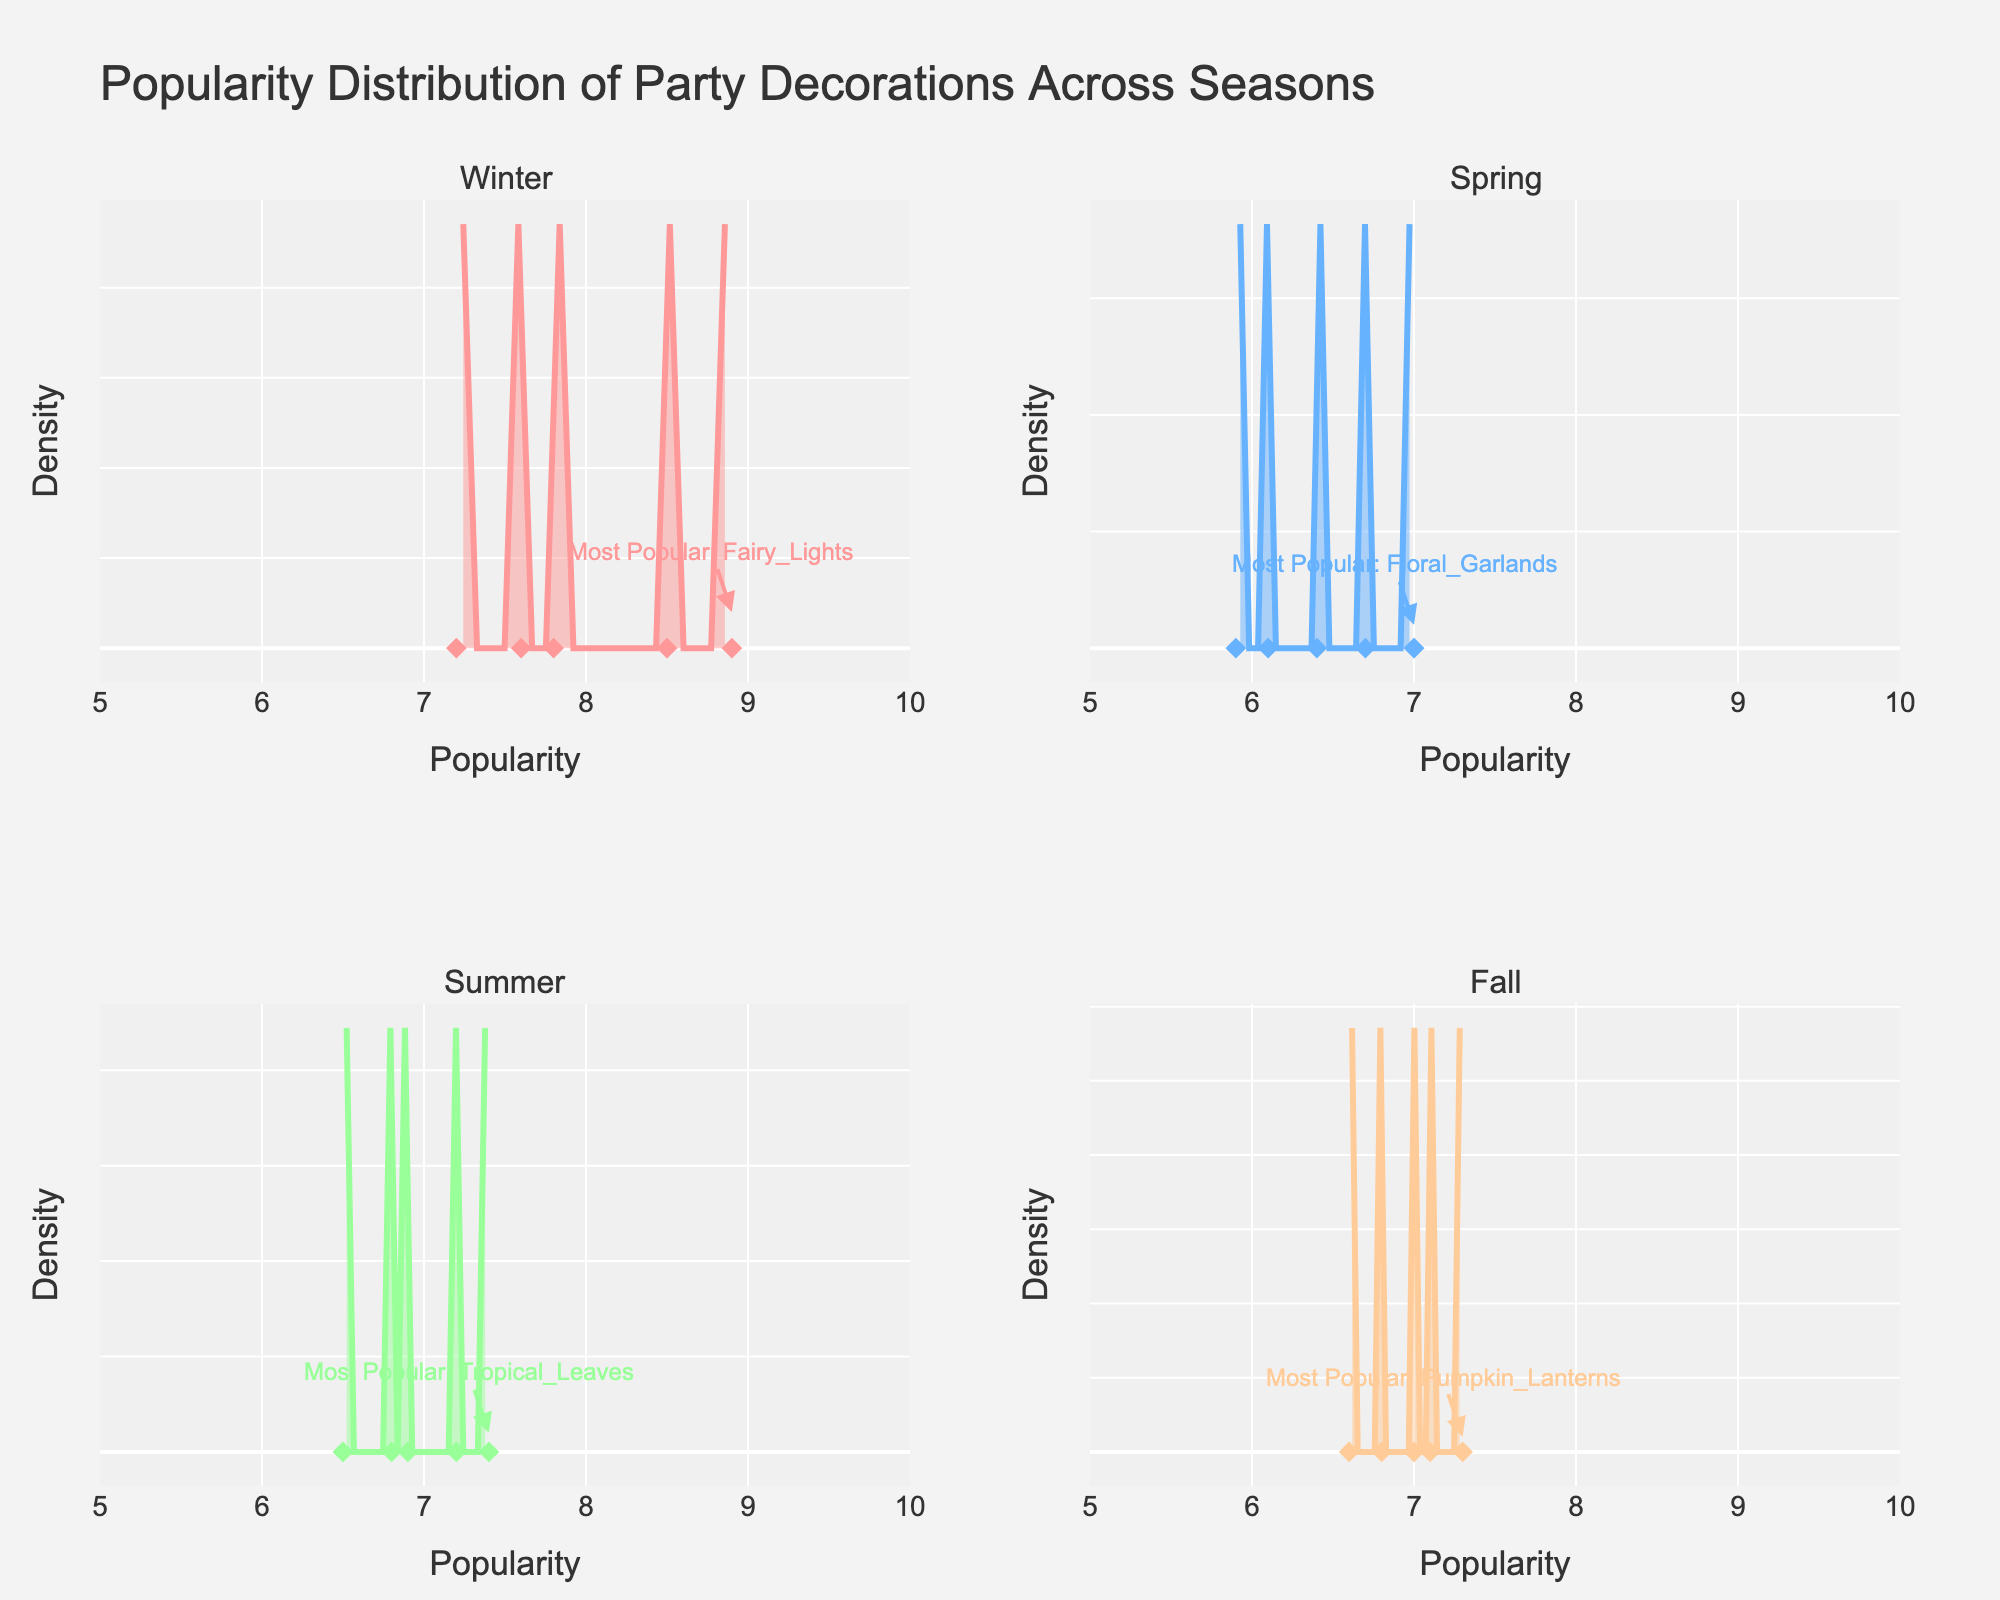What is the title of the figure? The title is usually placed at the top of the figure and clearly indicates what the data represents. In this case, it says "Popularity Distribution of Party Decorations Across Seasons."
Answer: Popularity Distribution of Party Decorations Across Seasons What is the popularity range of the decorations plotted in the figure? The x-axes of the density plots indicate the popularity range. It is set from 5 to 10 across all seasons.
Answer: 5 to 10 Which season has the most popular decoration with a popularity score of 8.9? Each subplot contains annotations for the most popular items in each season. The annotation in the Winter subplot indicates that the most popular decoration has a score of 8.9.
Answer: Winter How many seasons are compared in this figure? The subplot titles indicate the different seasons compared in the figure. There are four titles, corresponding to four different seasons.
Answer: 4 Which season has "Tropical Leaves" as a decoration type? The legend or scatter plot markers in the subplot for Summer would show the different data points, including "Tropical Leaves."
Answer: Summer What's the range of the y-axis representing density in the plots? The y-axes are consistent across all subplots and are labeled as "Density." They typically range from 0 to a peak value consistent with a density plot, here most likely up to around 0.6.
Answer: Up to around 0.6 Compare the median popularity of decorations in Spring and Fall. Which season has the higher median popularity? The median value can be visualized as the middle point of the density curves in each subplot. Judging by the symmetry of the density plots, Spring has decorations centered around 6.5-7, while Fall seems to center around 7.
Answer: Fall Which decoration is identified as the most popular in Fall? The annotation in the Fall subplot indicates the most popular decoration during this period. The text points to "Pumpkin Lanterns" as the most popular decoration.
Answer: Pumpkin Lanterns In which season do the density values have the widest spread? The widest spread of density values can be identified by how spread out the curve is along the x-axis. The Spring subplot appears to have the widest spread, with values ranging from lower to higher along the x-axis.
Answer: Spring What do the scatter plot markers in each subplot represent? The scatter plot markers below the density plots represent individual data points for decoration popularity scores within each season.
Answer: Individual data points 